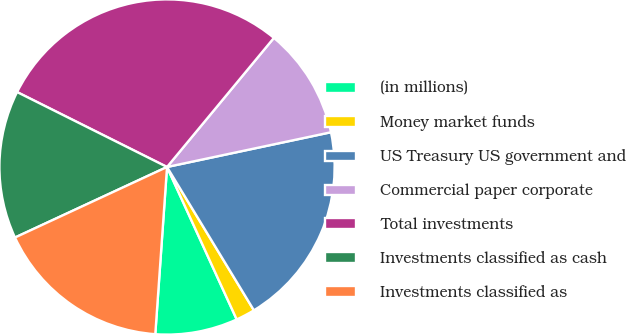Convert chart to OTSL. <chart><loc_0><loc_0><loc_500><loc_500><pie_chart><fcel>(in millions)<fcel>Money market funds<fcel>US Treasury US government and<fcel>Commercial paper corporate<fcel>Total investments<fcel>Investments classified as cash<fcel>Investments classified as<nl><fcel>7.94%<fcel>1.85%<fcel>19.65%<fcel>10.67%<fcel>28.63%<fcel>14.29%<fcel>16.97%<nl></chart> 